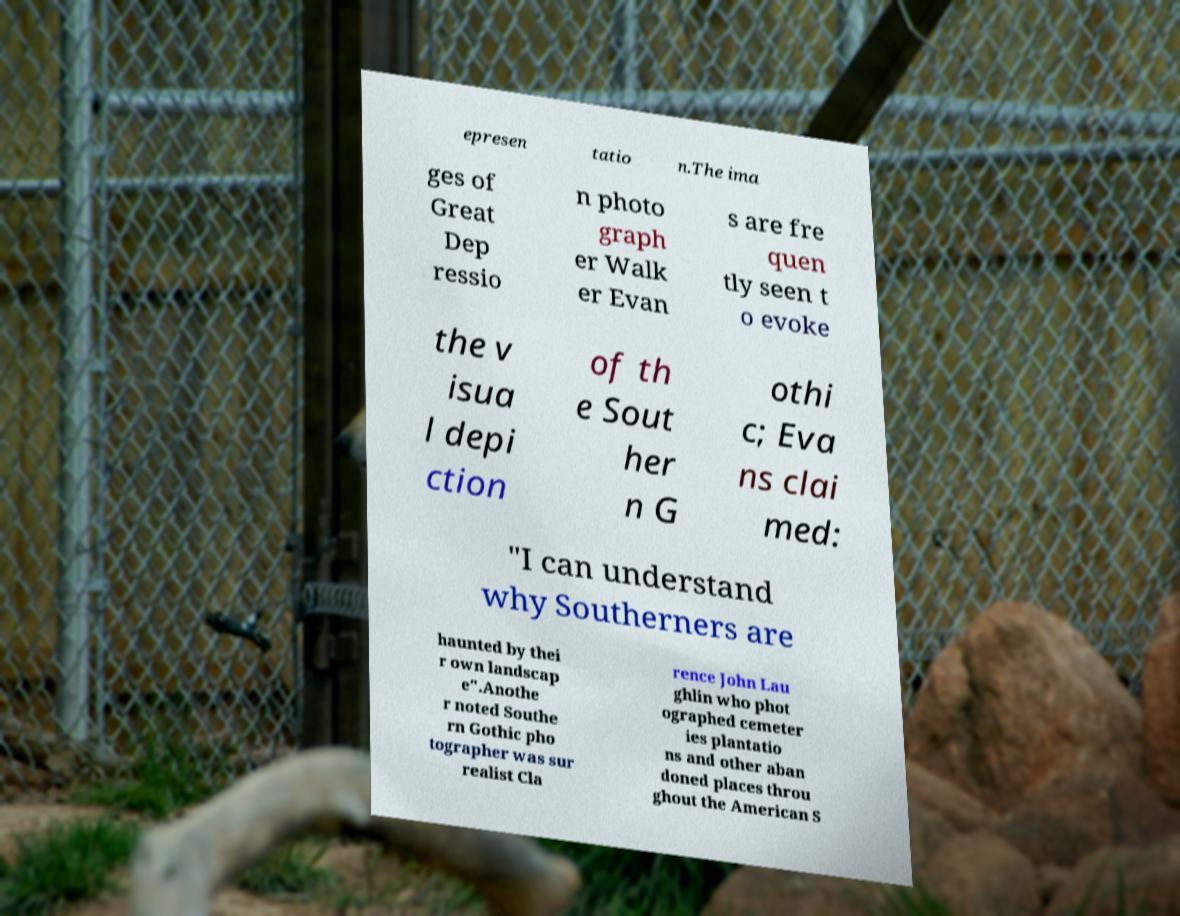Could you extract and type out the text from this image? epresen tatio n.The ima ges of Great Dep ressio n photo graph er Walk er Evan s are fre quen tly seen t o evoke the v isua l depi ction of th e Sout her n G othi c; Eva ns clai med: "I can understand why Southerners are haunted by thei r own landscap e".Anothe r noted Southe rn Gothic pho tographer was sur realist Cla rence John Lau ghlin who phot ographed cemeter ies plantatio ns and other aban doned places throu ghout the American S 